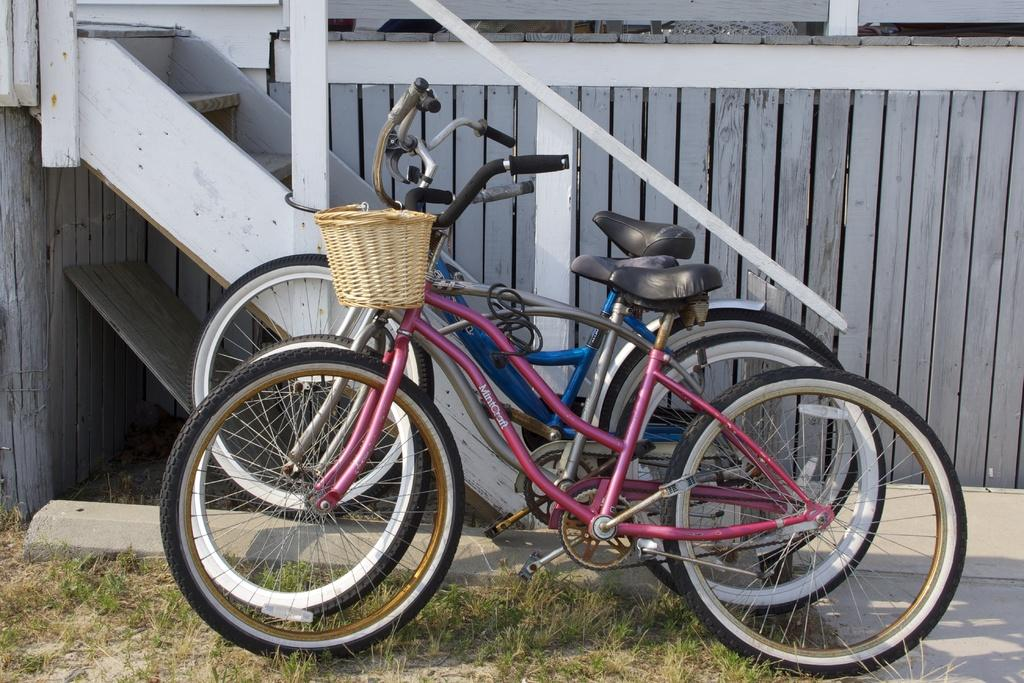How many bicycles are visible in the image? There are three bicycles in the image. What type of terrain is visible in the image? There is grass in the image. What can be seen in the background of the image? There is a board, a fence, and stairs in the background of the image. What color is the bead that is being stretched by the leg in the image? There is no bead or leg present in the image. 